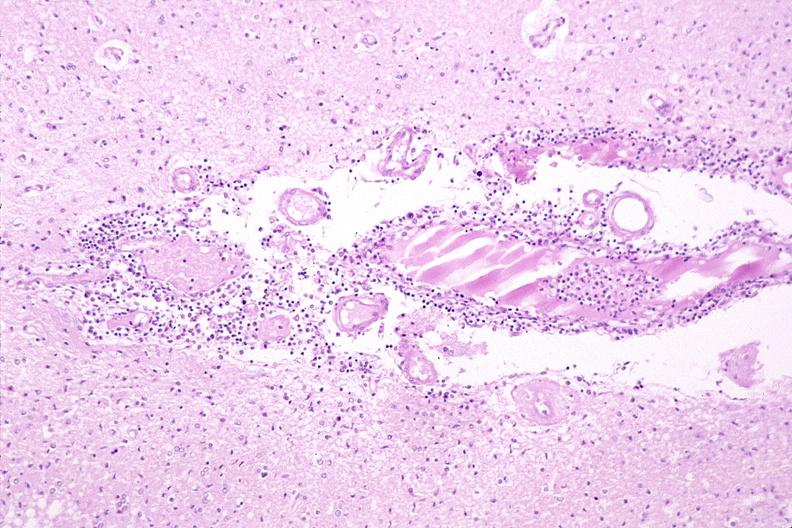what is present?
Answer the question using a single word or phrase. Nervous 